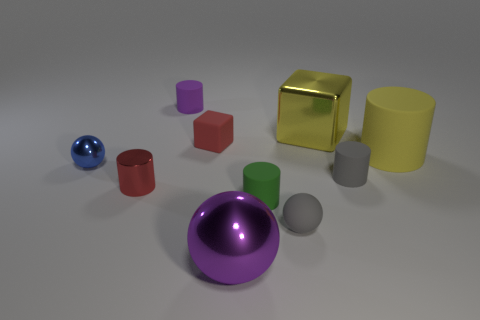Subtract 2 cylinders. How many cylinders are left? 3 Subtract all yellow cylinders. How many cylinders are left? 4 Subtract all tiny green cylinders. How many cylinders are left? 4 Subtract all gray cylinders. Subtract all yellow cubes. How many cylinders are left? 4 Subtract all spheres. How many objects are left? 7 Subtract 0 red balls. How many objects are left? 10 Subtract all purple shiny things. Subtract all tiny metallic balls. How many objects are left? 8 Add 8 small purple things. How many small purple things are left? 9 Add 2 large blue rubber objects. How many large blue rubber objects exist? 2 